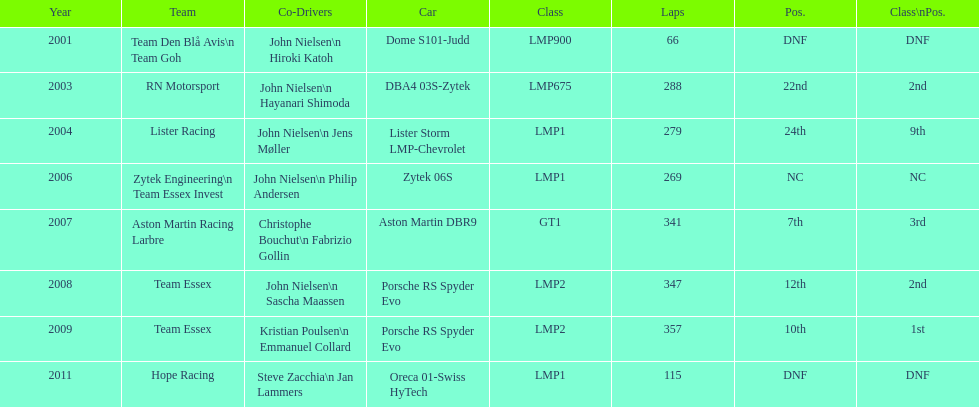For team lister in 2004, who served as john nielsen's fellow driver? Jens Møller. 